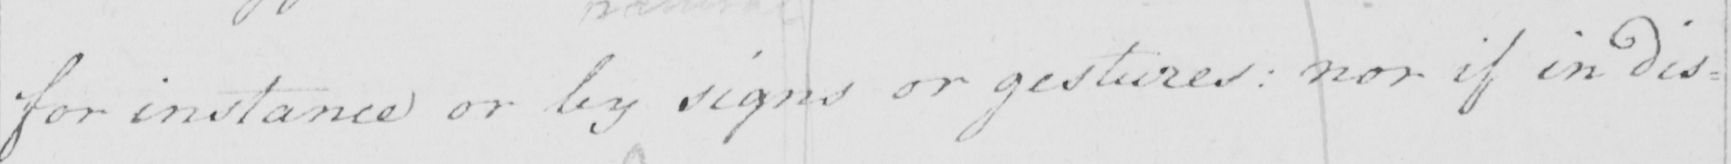Please provide the text content of this handwritten line. for instance or by signs or gestures nor if in dis= 